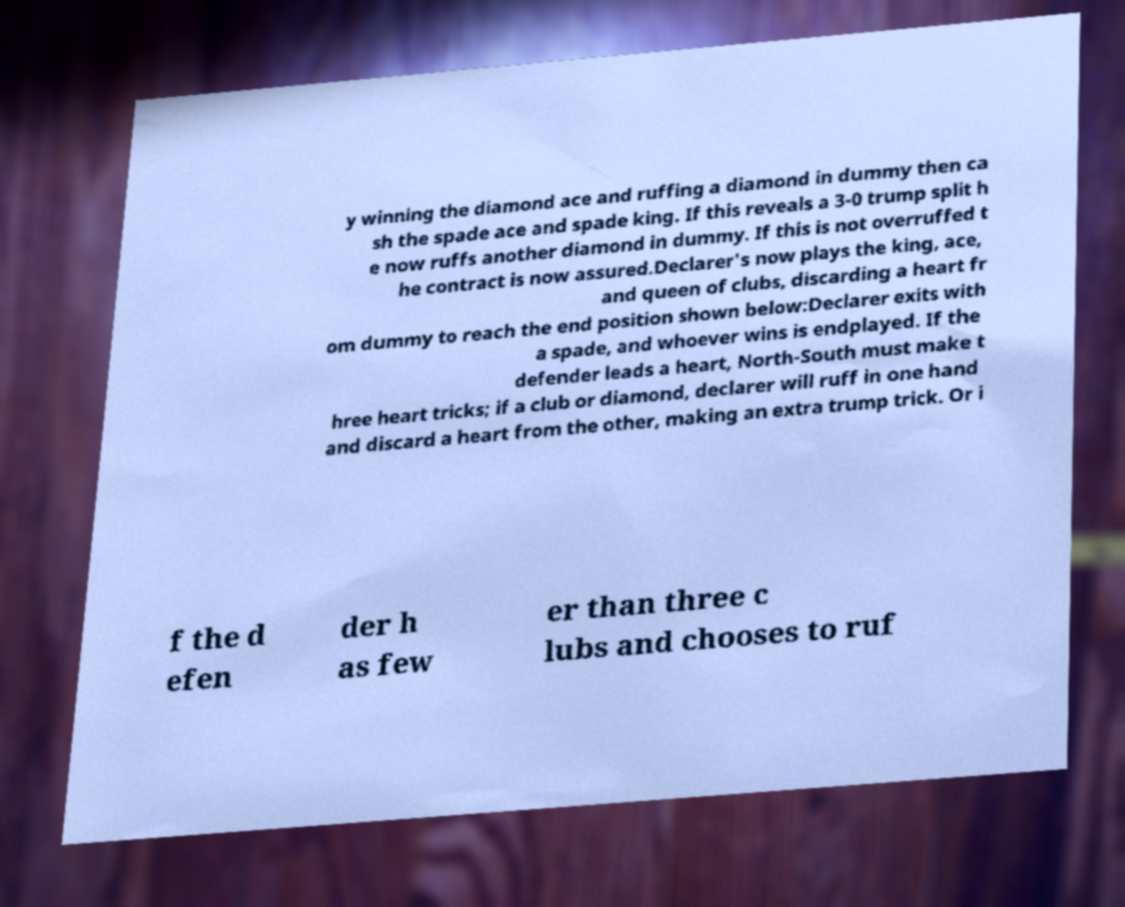What messages or text are displayed in this image? I need them in a readable, typed format. y winning the diamond ace and ruffing a diamond in dummy then ca sh the spade ace and spade king. If this reveals a 3-0 trump split h e now ruffs another diamond in dummy. If this is not overruffed t he contract is now assured.Declarer's now plays the king, ace, and queen of clubs, discarding a heart fr om dummy to reach the end position shown below:Declarer exits with a spade, and whoever wins is endplayed. If the defender leads a heart, North-South must make t hree heart tricks; if a club or diamond, declarer will ruff in one hand and discard a heart from the other, making an extra trump trick. Or i f the d efen der h as few er than three c lubs and chooses to ruf 